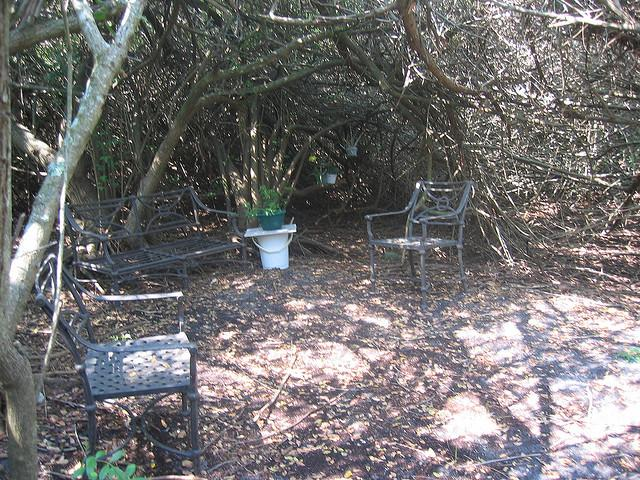What is near the flower pot? Please explain your reasoning. chair. A chair is near the flower pot 